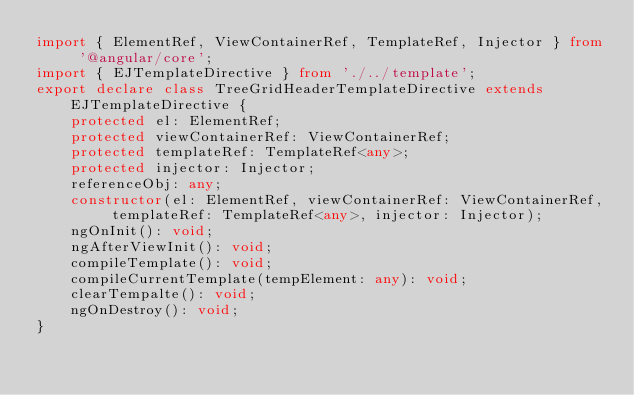<code> <loc_0><loc_0><loc_500><loc_500><_TypeScript_>import { ElementRef, ViewContainerRef, TemplateRef, Injector } from '@angular/core';
import { EJTemplateDirective } from './../template';
export declare class TreeGridHeaderTemplateDirective extends EJTemplateDirective {
    protected el: ElementRef;
    protected viewContainerRef: ViewContainerRef;
    protected templateRef: TemplateRef<any>;
    protected injector: Injector;
    referenceObj: any;
    constructor(el: ElementRef, viewContainerRef: ViewContainerRef, templateRef: TemplateRef<any>, injector: Injector);
    ngOnInit(): void;
    ngAfterViewInit(): void;
    compileTemplate(): void;
    compileCurrentTemplate(tempElement: any): void;
    clearTempalte(): void;
    ngOnDestroy(): void;
}
</code> 